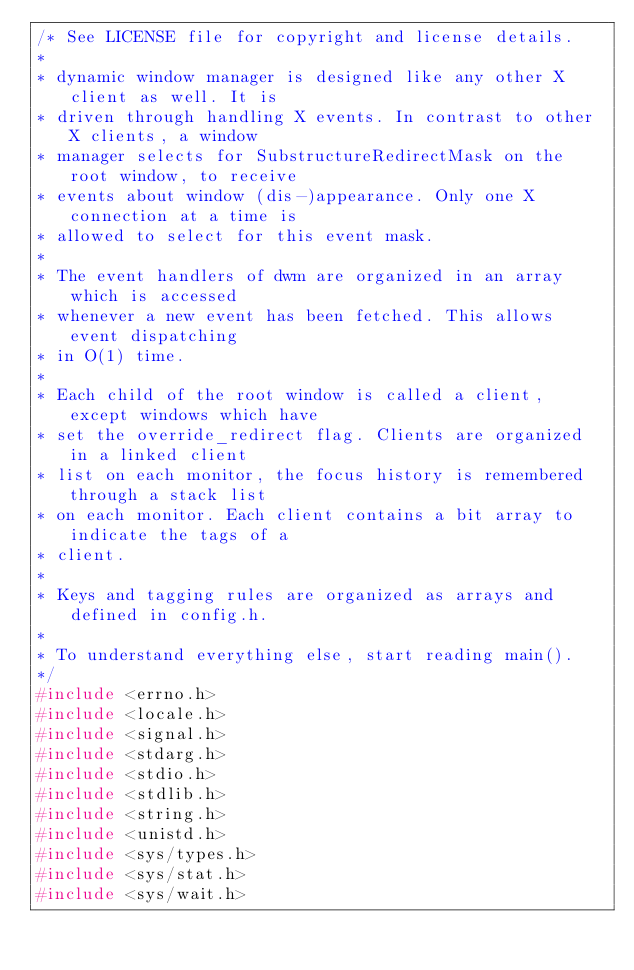Convert code to text. <code><loc_0><loc_0><loc_500><loc_500><_C_>/* See LICENSE file for copyright and license details.
*
* dynamic window manager is designed like any other X client as well. It is
* driven through handling X events. In contrast to other X clients, a window
* manager selects for SubstructureRedirectMask on the root window, to receive
* events about window (dis-)appearance. Only one X connection at a time is
* allowed to select for this event mask.
*
* The event handlers of dwm are organized in an array which is accessed
* whenever a new event has been fetched. This allows event dispatching
* in O(1) time.
*
* Each child of the root window is called a client, except windows which have
* set the override_redirect flag. Clients are organized in a linked client
* list on each monitor, the focus history is remembered through a stack list
* on each monitor. Each client contains a bit array to indicate the tags of a
* client.
*
* Keys and tagging rules are organized as arrays and defined in config.h.
*
* To understand everything else, start reading main().
*/
#include <errno.h>
#include <locale.h>
#include <signal.h>
#include <stdarg.h>
#include <stdio.h>
#include <stdlib.h>
#include <string.h>
#include <unistd.h>
#include <sys/types.h>
#include <sys/stat.h>
#include <sys/wait.h></code> 